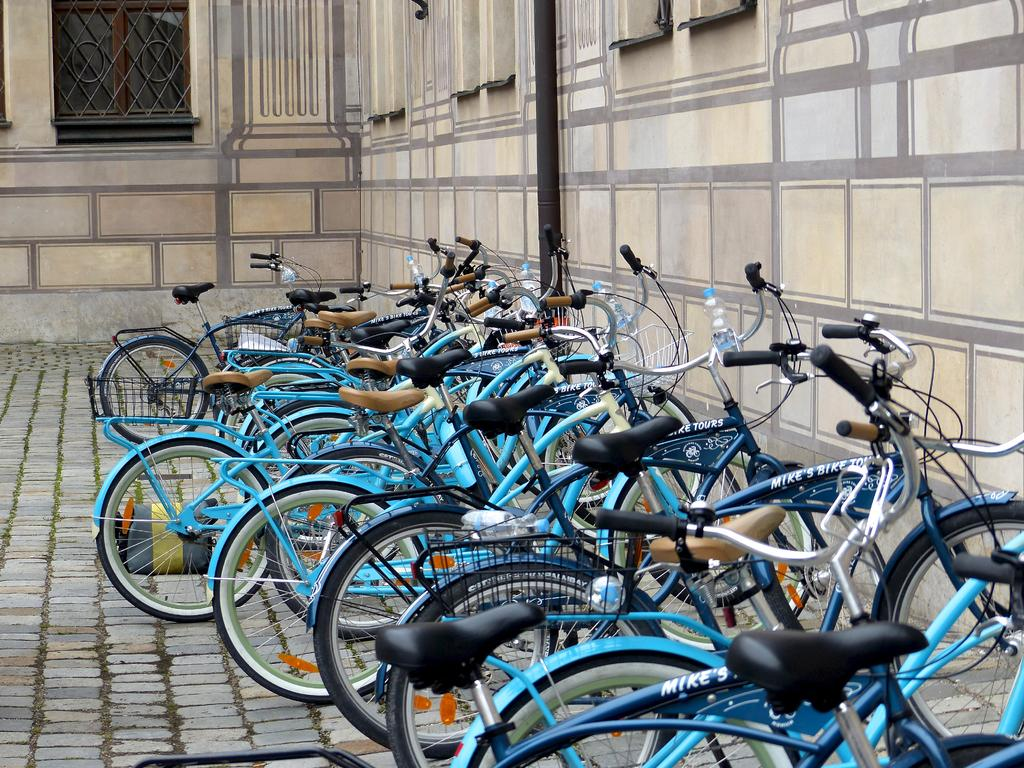What is the main subject of the image? There is a bicyclist in the image. Where is the bicyclist located? The bicyclist is on the ground. What other objects can be seen in the image? There is a pole, a window, and a wall in the image. Did the bicyclist attempt to ride through the wilderness in the image? There is no indication in the image that the bicyclist is attempting to ride through the wilderness, as the image does not depict any wilderness setting. 